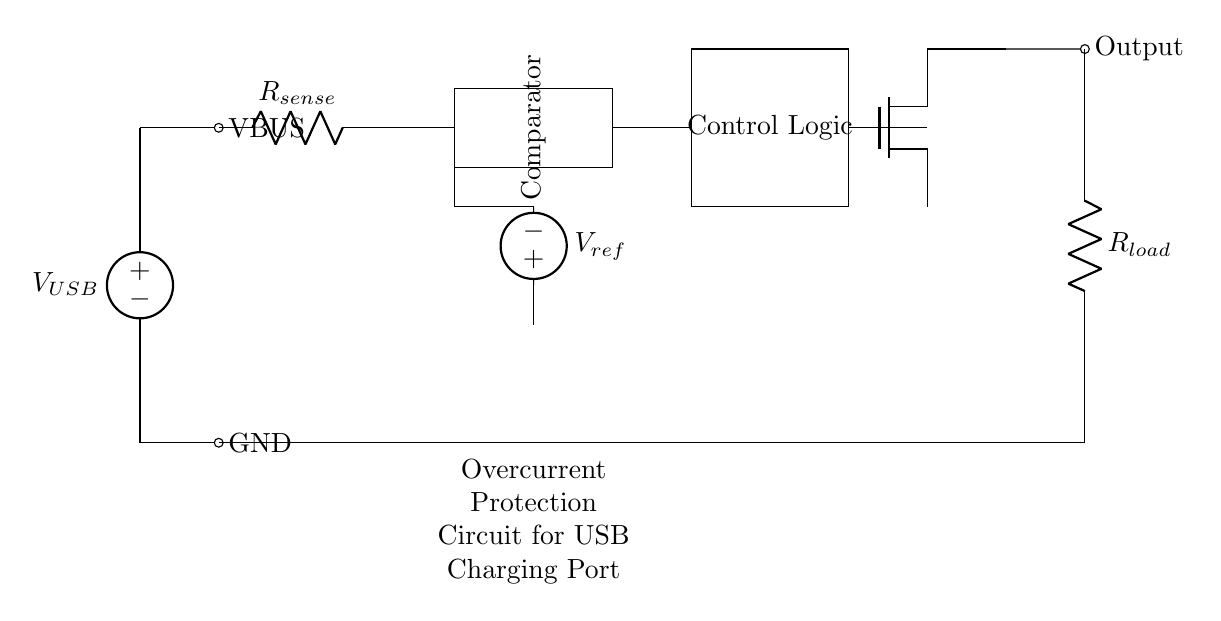What is the function of the current sense resistor? The current sense resistor is used to monitor the current flowing through the circuit by creating a small voltage drop proportional to the current. This voltage drop is used by the comparator to determine if the current exceeds a predetermined threshold.
Answer: Monitor current What component is responsible for controlling the output based on the current sensed? The control logic receives input from the comparator and determines whether to allow or cut off the output current based on the current level. If the current exceeds the limit, the control logic turns off the MOSFET switch.
Answer: Control logic What is the role of the comparator in this circuit? The comparator compares the voltage drop across the current sense resistor with a reference voltage. If the sensed voltage exceeds the reference voltage, it triggers the control logic to protect the circuit from overcurrent.
Answer: Compare voltages What happens if the current exceeds the reference voltage? If the current exceeds the reference voltage, the comparator sends a signal to the control logic to turn off the MOSFET switch, effectively disconnecting the load and protecting the USB charging port from damage.
Answer: MOSFET turns off What type of MOSFET is used in this circuit? The circuit uses a N-channel MOSFET as a switch, which is common in low-side switching applications, suitable for controlling the connection to the load based on the control signal.
Answer: N-channel What is the purpose of the reference voltage in this circuit? The reference voltage provides a threshold level that the sensed current voltage must not exceed. It sets the limit for overcurrent detection, ensuring the circuit only activates protection when necessary.
Answer: Overcurrent threshold 